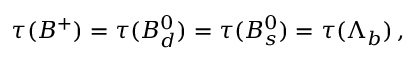Convert formula to latex. <formula><loc_0><loc_0><loc_500><loc_500>\tau ( B ^ { + } ) = \tau ( B _ { d } ^ { 0 } ) = \tau ( B _ { s } ^ { 0 } ) = \tau ( \Lambda _ { b } ) \, ,</formula> 